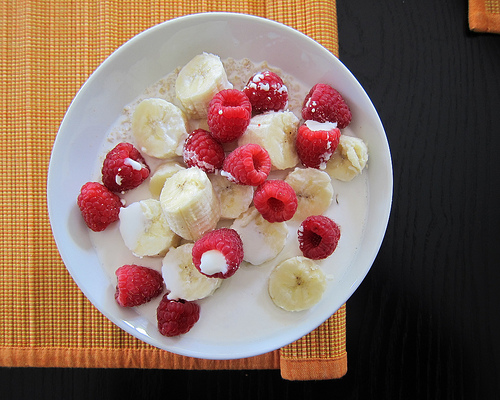<image>
Can you confirm if the strawberry is next to the table cloth? No. The strawberry is not positioned next to the table cloth. They are located in different areas of the scene. Is the berry above the milk? No. The berry is not positioned above the milk. The vertical arrangement shows a different relationship. Where is the raspberry in relation to the wooden placemat? Is it on the wooden placemat? No. The raspberry is not positioned on the wooden placemat. They may be near each other, but the raspberry is not supported by or resting on top of the wooden placemat. 